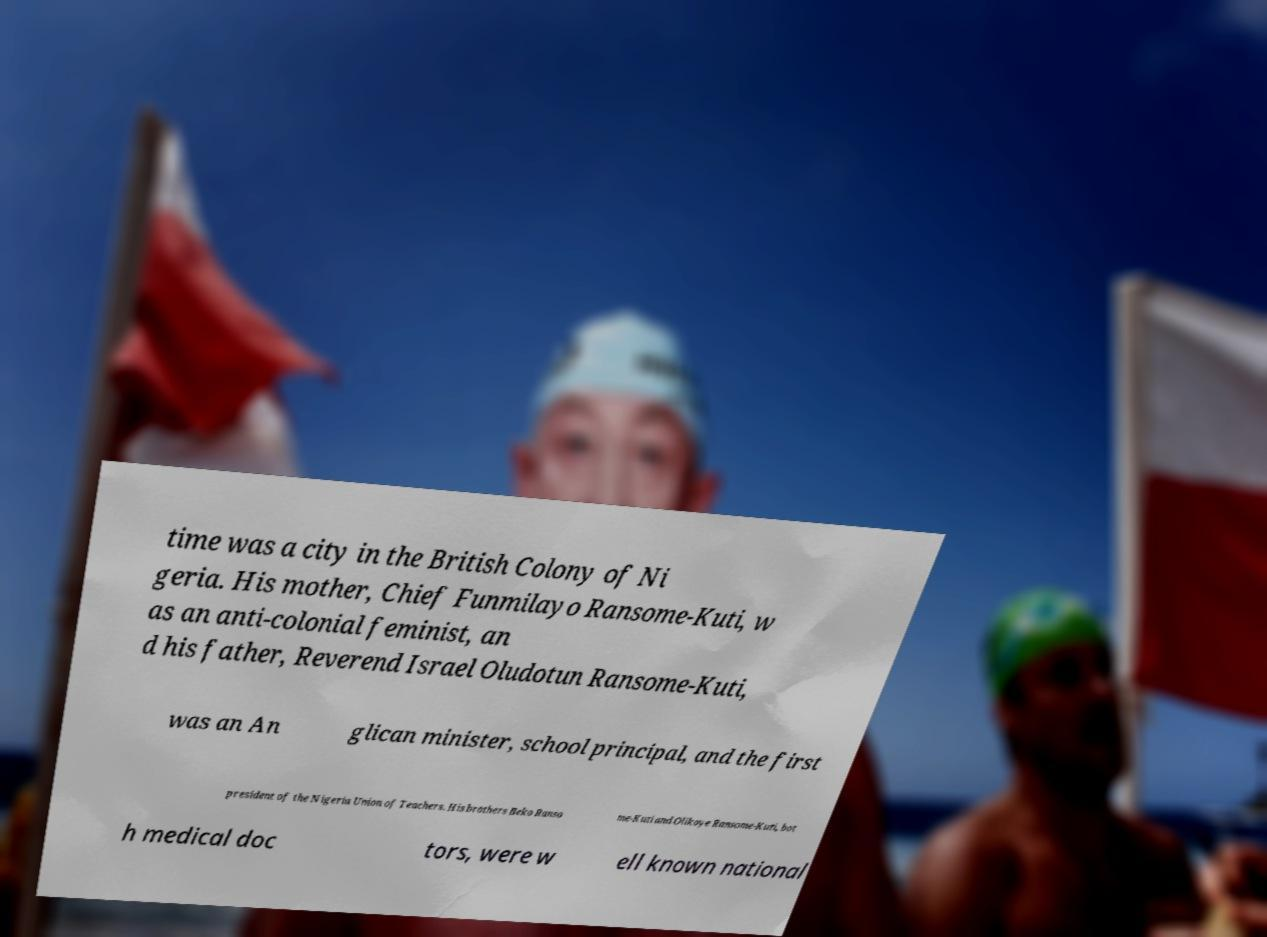Please read and relay the text visible in this image. What does it say? time was a city in the British Colony of Ni geria. His mother, Chief Funmilayo Ransome-Kuti, w as an anti-colonial feminist, an d his father, Reverend Israel Oludotun Ransome-Kuti, was an An glican minister, school principal, and the first president of the Nigeria Union of Teachers. His brothers Beko Ranso me-Kuti and Olikoye Ransome-Kuti, bot h medical doc tors, were w ell known national 